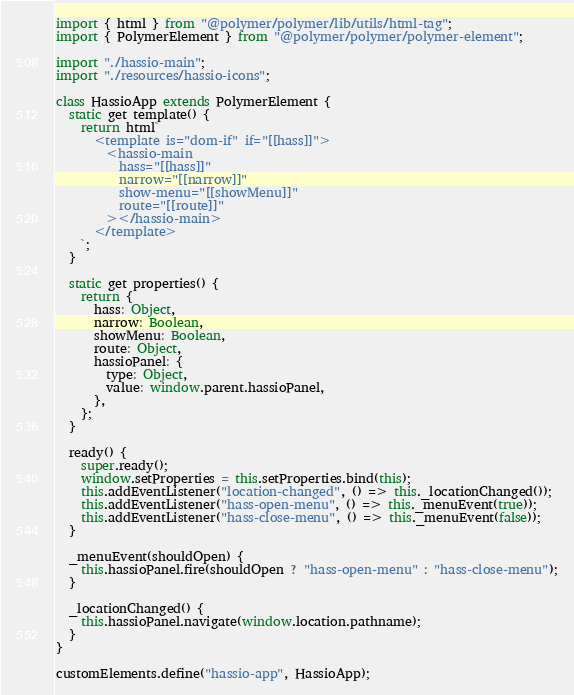<code> <loc_0><loc_0><loc_500><loc_500><_JavaScript_>import { html } from "@polymer/polymer/lib/utils/html-tag";
import { PolymerElement } from "@polymer/polymer/polymer-element";

import "./hassio-main";
import "./resources/hassio-icons";

class HassioApp extends PolymerElement {
  static get template() {
    return html`
      <template is="dom-if" if="[[hass]]">
        <hassio-main
          hass="[[hass]]"
          narrow="[[narrow]]"
          show-menu="[[showMenu]]"
          route="[[route]]"
        ></hassio-main>
      </template>
    `;
  }

  static get properties() {
    return {
      hass: Object,
      narrow: Boolean,
      showMenu: Boolean,
      route: Object,
      hassioPanel: {
        type: Object,
        value: window.parent.hassioPanel,
      },
    };
  }

  ready() {
    super.ready();
    window.setProperties = this.setProperties.bind(this);
    this.addEventListener("location-changed", () => this._locationChanged());
    this.addEventListener("hass-open-menu", () => this._menuEvent(true));
    this.addEventListener("hass-close-menu", () => this._menuEvent(false));
  }

  _menuEvent(shouldOpen) {
    this.hassioPanel.fire(shouldOpen ? "hass-open-menu" : "hass-close-menu");
  }

  _locationChanged() {
    this.hassioPanel.navigate(window.location.pathname);
  }
}

customElements.define("hassio-app", HassioApp);
</code> 